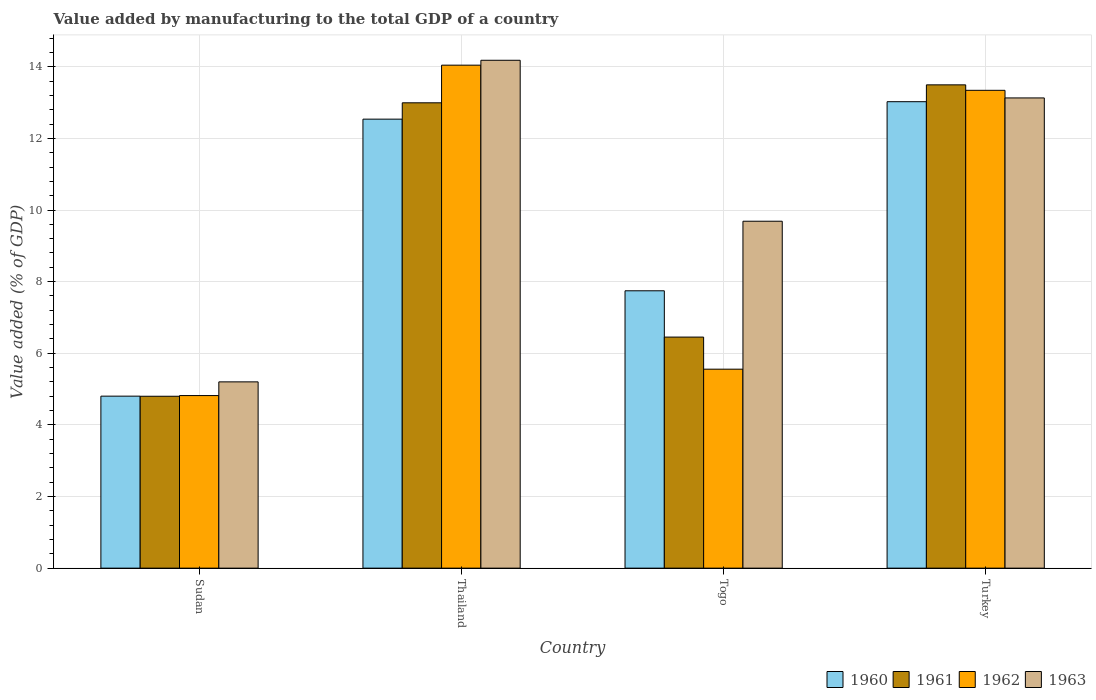How many different coloured bars are there?
Provide a succinct answer. 4. How many groups of bars are there?
Provide a succinct answer. 4. Are the number of bars per tick equal to the number of legend labels?
Offer a terse response. Yes. How many bars are there on the 2nd tick from the left?
Your response must be concise. 4. How many bars are there on the 1st tick from the right?
Keep it short and to the point. 4. What is the label of the 4th group of bars from the left?
Give a very brief answer. Turkey. What is the value added by manufacturing to the total GDP in 1962 in Thailand?
Offer a very short reply. 14.04. Across all countries, what is the maximum value added by manufacturing to the total GDP in 1960?
Offer a terse response. 13.02. Across all countries, what is the minimum value added by manufacturing to the total GDP in 1960?
Your response must be concise. 4.8. In which country was the value added by manufacturing to the total GDP in 1961 maximum?
Provide a succinct answer. Turkey. In which country was the value added by manufacturing to the total GDP in 1961 minimum?
Keep it short and to the point. Sudan. What is the total value added by manufacturing to the total GDP in 1963 in the graph?
Keep it short and to the point. 42.2. What is the difference between the value added by manufacturing to the total GDP in 1960 in Sudan and that in Togo?
Provide a short and direct response. -2.94. What is the difference between the value added by manufacturing to the total GDP in 1960 in Turkey and the value added by manufacturing to the total GDP in 1963 in Togo?
Keep it short and to the point. 3.34. What is the average value added by manufacturing to the total GDP in 1963 per country?
Offer a very short reply. 10.55. What is the difference between the value added by manufacturing to the total GDP of/in 1962 and value added by manufacturing to the total GDP of/in 1963 in Thailand?
Your answer should be compact. -0.14. In how many countries, is the value added by manufacturing to the total GDP in 1961 greater than 14 %?
Provide a succinct answer. 0. What is the ratio of the value added by manufacturing to the total GDP in 1961 in Thailand to that in Togo?
Ensure brevity in your answer.  2.01. Is the value added by manufacturing to the total GDP in 1962 in Sudan less than that in Thailand?
Offer a very short reply. Yes. Is the difference between the value added by manufacturing to the total GDP in 1962 in Sudan and Togo greater than the difference between the value added by manufacturing to the total GDP in 1963 in Sudan and Togo?
Make the answer very short. Yes. What is the difference between the highest and the second highest value added by manufacturing to the total GDP in 1963?
Offer a very short reply. -3.44. What is the difference between the highest and the lowest value added by manufacturing to the total GDP in 1961?
Your answer should be very brief. 8.69. In how many countries, is the value added by manufacturing to the total GDP in 1962 greater than the average value added by manufacturing to the total GDP in 1962 taken over all countries?
Provide a short and direct response. 2. Is the sum of the value added by manufacturing to the total GDP in 1961 in Sudan and Togo greater than the maximum value added by manufacturing to the total GDP in 1962 across all countries?
Give a very brief answer. No. Is it the case that in every country, the sum of the value added by manufacturing to the total GDP in 1960 and value added by manufacturing to the total GDP in 1963 is greater than the sum of value added by manufacturing to the total GDP in 1961 and value added by manufacturing to the total GDP in 1962?
Make the answer very short. No. What does the 2nd bar from the right in Thailand represents?
Your response must be concise. 1962. How many countries are there in the graph?
Your response must be concise. 4. What is the difference between two consecutive major ticks on the Y-axis?
Give a very brief answer. 2. Does the graph contain any zero values?
Offer a very short reply. No. Does the graph contain grids?
Provide a succinct answer. Yes. Where does the legend appear in the graph?
Your answer should be very brief. Bottom right. How many legend labels are there?
Your answer should be compact. 4. What is the title of the graph?
Your response must be concise. Value added by manufacturing to the total GDP of a country. Does "1989" appear as one of the legend labels in the graph?
Ensure brevity in your answer.  No. What is the label or title of the X-axis?
Keep it short and to the point. Country. What is the label or title of the Y-axis?
Provide a short and direct response. Value added (% of GDP). What is the Value added (% of GDP) of 1960 in Sudan?
Offer a very short reply. 4.8. What is the Value added (% of GDP) in 1961 in Sudan?
Provide a succinct answer. 4.8. What is the Value added (% of GDP) in 1962 in Sudan?
Provide a short and direct response. 4.82. What is the Value added (% of GDP) in 1963 in Sudan?
Give a very brief answer. 5.2. What is the Value added (% of GDP) of 1960 in Thailand?
Your response must be concise. 12.54. What is the Value added (% of GDP) in 1961 in Thailand?
Give a very brief answer. 12.99. What is the Value added (% of GDP) of 1962 in Thailand?
Give a very brief answer. 14.04. What is the Value added (% of GDP) in 1963 in Thailand?
Provide a succinct answer. 14.18. What is the Value added (% of GDP) of 1960 in Togo?
Give a very brief answer. 7.74. What is the Value added (% of GDP) in 1961 in Togo?
Offer a very short reply. 6.45. What is the Value added (% of GDP) of 1962 in Togo?
Provide a succinct answer. 5.56. What is the Value added (% of GDP) in 1963 in Togo?
Make the answer very short. 9.69. What is the Value added (% of GDP) of 1960 in Turkey?
Ensure brevity in your answer.  13.02. What is the Value added (% of GDP) of 1961 in Turkey?
Your response must be concise. 13.49. What is the Value added (% of GDP) in 1962 in Turkey?
Give a very brief answer. 13.34. What is the Value added (% of GDP) in 1963 in Turkey?
Offer a very short reply. 13.13. Across all countries, what is the maximum Value added (% of GDP) of 1960?
Your answer should be very brief. 13.02. Across all countries, what is the maximum Value added (% of GDP) in 1961?
Your answer should be compact. 13.49. Across all countries, what is the maximum Value added (% of GDP) of 1962?
Ensure brevity in your answer.  14.04. Across all countries, what is the maximum Value added (% of GDP) in 1963?
Provide a short and direct response. 14.18. Across all countries, what is the minimum Value added (% of GDP) in 1960?
Provide a succinct answer. 4.8. Across all countries, what is the minimum Value added (% of GDP) in 1961?
Offer a very short reply. 4.8. Across all countries, what is the minimum Value added (% of GDP) in 1962?
Give a very brief answer. 4.82. Across all countries, what is the minimum Value added (% of GDP) in 1963?
Make the answer very short. 5.2. What is the total Value added (% of GDP) in 1960 in the graph?
Make the answer very short. 38.11. What is the total Value added (% of GDP) in 1961 in the graph?
Ensure brevity in your answer.  37.74. What is the total Value added (% of GDP) in 1962 in the graph?
Your answer should be compact. 37.76. What is the total Value added (% of GDP) of 1963 in the graph?
Offer a very short reply. 42.2. What is the difference between the Value added (% of GDP) in 1960 in Sudan and that in Thailand?
Your response must be concise. -7.73. What is the difference between the Value added (% of GDP) in 1961 in Sudan and that in Thailand?
Keep it short and to the point. -8.19. What is the difference between the Value added (% of GDP) in 1962 in Sudan and that in Thailand?
Make the answer very short. -9.23. What is the difference between the Value added (% of GDP) in 1963 in Sudan and that in Thailand?
Offer a very short reply. -8.98. What is the difference between the Value added (% of GDP) of 1960 in Sudan and that in Togo?
Provide a succinct answer. -2.94. What is the difference between the Value added (% of GDP) of 1961 in Sudan and that in Togo?
Keep it short and to the point. -1.65. What is the difference between the Value added (% of GDP) in 1962 in Sudan and that in Togo?
Ensure brevity in your answer.  -0.74. What is the difference between the Value added (% of GDP) in 1963 in Sudan and that in Togo?
Offer a terse response. -4.49. What is the difference between the Value added (% of GDP) in 1960 in Sudan and that in Turkey?
Provide a short and direct response. -8.22. What is the difference between the Value added (% of GDP) in 1961 in Sudan and that in Turkey?
Your response must be concise. -8.69. What is the difference between the Value added (% of GDP) in 1962 in Sudan and that in Turkey?
Ensure brevity in your answer.  -8.52. What is the difference between the Value added (% of GDP) in 1963 in Sudan and that in Turkey?
Offer a terse response. -7.93. What is the difference between the Value added (% of GDP) in 1960 in Thailand and that in Togo?
Provide a succinct answer. 4.79. What is the difference between the Value added (% of GDP) of 1961 in Thailand and that in Togo?
Provide a short and direct response. 6.54. What is the difference between the Value added (% of GDP) in 1962 in Thailand and that in Togo?
Offer a terse response. 8.49. What is the difference between the Value added (% of GDP) in 1963 in Thailand and that in Togo?
Keep it short and to the point. 4.49. What is the difference between the Value added (% of GDP) of 1960 in Thailand and that in Turkey?
Make the answer very short. -0.49. What is the difference between the Value added (% of GDP) of 1961 in Thailand and that in Turkey?
Offer a very short reply. -0.5. What is the difference between the Value added (% of GDP) of 1962 in Thailand and that in Turkey?
Ensure brevity in your answer.  0.7. What is the difference between the Value added (% of GDP) of 1963 in Thailand and that in Turkey?
Give a very brief answer. 1.05. What is the difference between the Value added (% of GDP) of 1960 in Togo and that in Turkey?
Provide a short and direct response. -5.28. What is the difference between the Value added (% of GDP) in 1961 in Togo and that in Turkey?
Your answer should be very brief. -7.04. What is the difference between the Value added (% of GDP) of 1962 in Togo and that in Turkey?
Provide a succinct answer. -7.79. What is the difference between the Value added (% of GDP) of 1963 in Togo and that in Turkey?
Provide a succinct answer. -3.44. What is the difference between the Value added (% of GDP) of 1960 in Sudan and the Value added (% of GDP) of 1961 in Thailand?
Give a very brief answer. -8.19. What is the difference between the Value added (% of GDP) of 1960 in Sudan and the Value added (% of GDP) of 1962 in Thailand?
Give a very brief answer. -9.24. What is the difference between the Value added (% of GDP) of 1960 in Sudan and the Value added (% of GDP) of 1963 in Thailand?
Keep it short and to the point. -9.38. What is the difference between the Value added (% of GDP) in 1961 in Sudan and the Value added (% of GDP) in 1962 in Thailand?
Provide a succinct answer. -9.24. What is the difference between the Value added (% of GDP) of 1961 in Sudan and the Value added (% of GDP) of 1963 in Thailand?
Offer a very short reply. -9.38. What is the difference between the Value added (% of GDP) in 1962 in Sudan and the Value added (% of GDP) in 1963 in Thailand?
Give a very brief answer. -9.36. What is the difference between the Value added (% of GDP) of 1960 in Sudan and the Value added (% of GDP) of 1961 in Togo?
Give a very brief answer. -1.65. What is the difference between the Value added (% of GDP) in 1960 in Sudan and the Value added (% of GDP) in 1962 in Togo?
Provide a short and direct response. -0.75. What is the difference between the Value added (% of GDP) of 1960 in Sudan and the Value added (% of GDP) of 1963 in Togo?
Offer a very short reply. -4.88. What is the difference between the Value added (% of GDP) in 1961 in Sudan and the Value added (% of GDP) in 1962 in Togo?
Ensure brevity in your answer.  -0.76. What is the difference between the Value added (% of GDP) of 1961 in Sudan and the Value added (% of GDP) of 1963 in Togo?
Provide a succinct answer. -4.89. What is the difference between the Value added (% of GDP) in 1962 in Sudan and the Value added (% of GDP) in 1963 in Togo?
Your answer should be compact. -4.87. What is the difference between the Value added (% of GDP) of 1960 in Sudan and the Value added (% of GDP) of 1961 in Turkey?
Offer a terse response. -8.69. What is the difference between the Value added (% of GDP) in 1960 in Sudan and the Value added (% of GDP) in 1962 in Turkey?
Make the answer very short. -8.54. What is the difference between the Value added (% of GDP) in 1960 in Sudan and the Value added (% of GDP) in 1963 in Turkey?
Offer a very short reply. -8.33. What is the difference between the Value added (% of GDP) of 1961 in Sudan and the Value added (% of GDP) of 1962 in Turkey?
Your response must be concise. -8.54. What is the difference between the Value added (% of GDP) in 1961 in Sudan and the Value added (% of GDP) in 1963 in Turkey?
Offer a very short reply. -8.33. What is the difference between the Value added (% of GDP) in 1962 in Sudan and the Value added (% of GDP) in 1963 in Turkey?
Make the answer very short. -8.31. What is the difference between the Value added (% of GDP) in 1960 in Thailand and the Value added (% of GDP) in 1961 in Togo?
Your answer should be very brief. 6.09. What is the difference between the Value added (% of GDP) in 1960 in Thailand and the Value added (% of GDP) in 1962 in Togo?
Keep it short and to the point. 6.98. What is the difference between the Value added (% of GDP) of 1960 in Thailand and the Value added (% of GDP) of 1963 in Togo?
Your answer should be very brief. 2.85. What is the difference between the Value added (% of GDP) of 1961 in Thailand and the Value added (% of GDP) of 1962 in Togo?
Make the answer very short. 7.44. What is the difference between the Value added (% of GDP) in 1961 in Thailand and the Value added (% of GDP) in 1963 in Togo?
Your answer should be very brief. 3.31. What is the difference between the Value added (% of GDP) in 1962 in Thailand and the Value added (% of GDP) in 1963 in Togo?
Offer a terse response. 4.36. What is the difference between the Value added (% of GDP) in 1960 in Thailand and the Value added (% of GDP) in 1961 in Turkey?
Your answer should be compact. -0.96. What is the difference between the Value added (% of GDP) in 1960 in Thailand and the Value added (% of GDP) in 1962 in Turkey?
Ensure brevity in your answer.  -0.81. What is the difference between the Value added (% of GDP) in 1960 in Thailand and the Value added (% of GDP) in 1963 in Turkey?
Your answer should be compact. -0.59. What is the difference between the Value added (% of GDP) of 1961 in Thailand and the Value added (% of GDP) of 1962 in Turkey?
Your answer should be very brief. -0.35. What is the difference between the Value added (% of GDP) of 1961 in Thailand and the Value added (% of GDP) of 1963 in Turkey?
Your answer should be compact. -0.14. What is the difference between the Value added (% of GDP) of 1962 in Thailand and the Value added (% of GDP) of 1963 in Turkey?
Keep it short and to the point. 0.92. What is the difference between the Value added (% of GDP) of 1960 in Togo and the Value added (% of GDP) of 1961 in Turkey?
Your answer should be very brief. -5.75. What is the difference between the Value added (% of GDP) of 1960 in Togo and the Value added (% of GDP) of 1962 in Turkey?
Make the answer very short. -5.6. What is the difference between the Value added (% of GDP) of 1960 in Togo and the Value added (% of GDP) of 1963 in Turkey?
Offer a very short reply. -5.38. What is the difference between the Value added (% of GDP) of 1961 in Togo and the Value added (% of GDP) of 1962 in Turkey?
Give a very brief answer. -6.89. What is the difference between the Value added (% of GDP) in 1961 in Togo and the Value added (% of GDP) in 1963 in Turkey?
Offer a terse response. -6.68. What is the difference between the Value added (% of GDP) of 1962 in Togo and the Value added (% of GDP) of 1963 in Turkey?
Your answer should be very brief. -7.57. What is the average Value added (% of GDP) in 1960 per country?
Keep it short and to the point. 9.53. What is the average Value added (% of GDP) in 1961 per country?
Provide a short and direct response. 9.43. What is the average Value added (% of GDP) in 1962 per country?
Keep it short and to the point. 9.44. What is the average Value added (% of GDP) in 1963 per country?
Your response must be concise. 10.55. What is the difference between the Value added (% of GDP) of 1960 and Value added (% of GDP) of 1961 in Sudan?
Keep it short and to the point. 0. What is the difference between the Value added (% of GDP) of 1960 and Value added (% of GDP) of 1962 in Sudan?
Give a very brief answer. -0.02. What is the difference between the Value added (% of GDP) in 1960 and Value added (% of GDP) in 1963 in Sudan?
Ensure brevity in your answer.  -0.4. What is the difference between the Value added (% of GDP) in 1961 and Value added (% of GDP) in 1962 in Sudan?
Offer a very short reply. -0.02. What is the difference between the Value added (% of GDP) in 1961 and Value added (% of GDP) in 1963 in Sudan?
Keep it short and to the point. -0.4. What is the difference between the Value added (% of GDP) in 1962 and Value added (% of GDP) in 1963 in Sudan?
Make the answer very short. -0.38. What is the difference between the Value added (% of GDP) in 1960 and Value added (% of GDP) in 1961 in Thailand?
Provide a short and direct response. -0.46. What is the difference between the Value added (% of GDP) in 1960 and Value added (% of GDP) in 1962 in Thailand?
Offer a very short reply. -1.51. What is the difference between the Value added (% of GDP) of 1960 and Value added (% of GDP) of 1963 in Thailand?
Provide a succinct answer. -1.64. What is the difference between the Value added (% of GDP) of 1961 and Value added (% of GDP) of 1962 in Thailand?
Offer a terse response. -1.05. What is the difference between the Value added (% of GDP) of 1961 and Value added (% of GDP) of 1963 in Thailand?
Offer a very short reply. -1.19. What is the difference between the Value added (% of GDP) in 1962 and Value added (% of GDP) in 1963 in Thailand?
Offer a terse response. -0.14. What is the difference between the Value added (% of GDP) of 1960 and Value added (% of GDP) of 1961 in Togo?
Offer a very short reply. 1.29. What is the difference between the Value added (% of GDP) of 1960 and Value added (% of GDP) of 1962 in Togo?
Your answer should be compact. 2.19. What is the difference between the Value added (% of GDP) of 1960 and Value added (% of GDP) of 1963 in Togo?
Your answer should be compact. -1.94. What is the difference between the Value added (% of GDP) in 1961 and Value added (% of GDP) in 1962 in Togo?
Ensure brevity in your answer.  0.9. What is the difference between the Value added (% of GDP) of 1961 and Value added (% of GDP) of 1963 in Togo?
Offer a terse response. -3.23. What is the difference between the Value added (% of GDP) in 1962 and Value added (% of GDP) in 1963 in Togo?
Give a very brief answer. -4.13. What is the difference between the Value added (% of GDP) in 1960 and Value added (% of GDP) in 1961 in Turkey?
Offer a terse response. -0.47. What is the difference between the Value added (% of GDP) in 1960 and Value added (% of GDP) in 1962 in Turkey?
Provide a short and direct response. -0.32. What is the difference between the Value added (% of GDP) in 1960 and Value added (% of GDP) in 1963 in Turkey?
Offer a very short reply. -0.11. What is the difference between the Value added (% of GDP) in 1961 and Value added (% of GDP) in 1962 in Turkey?
Provide a succinct answer. 0.15. What is the difference between the Value added (% of GDP) of 1961 and Value added (% of GDP) of 1963 in Turkey?
Provide a short and direct response. 0.37. What is the difference between the Value added (% of GDP) of 1962 and Value added (% of GDP) of 1963 in Turkey?
Give a very brief answer. 0.21. What is the ratio of the Value added (% of GDP) in 1960 in Sudan to that in Thailand?
Give a very brief answer. 0.38. What is the ratio of the Value added (% of GDP) of 1961 in Sudan to that in Thailand?
Make the answer very short. 0.37. What is the ratio of the Value added (% of GDP) in 1962 in Sudan to that in Thailand?
Give a very brief answer. 0.34. What is the ratio of the Value added (% of GDP) in 1963 in Sudan to that in Thailand?
Your response must be concise. 0.37. What is the ratio of the Value added (% of GDP) in 1960 in Sudan to that in Togo?
Ensure brevity in your answer.  0.62. What is the ratio of the Value added (% of GDP) in 1961 in Sudan to that in Togo?
Ensure brevity in your answer.  0.74. What is the ratio of the Value added (% of GDP) of 1962 in Sudan to that in Togo?
Make the answer very short. 0.87. What is the ratio of the Value added (% of GDP) of 1963 in Sudan to that in Togo?
Your response must be concise. 0.54. What is the ratio of the Value added (% of GDP) of 1960 in Sudan to that in Turkey?
Make the answer very short. 0.37. What is the ratio of the Value added (% of GDP) in 1961 in Sudan to that in Turkey?
Keep it short and to the point. 0.36. What is the ratio of the Value added (% of GDP) in 1962 in Sudan to that in Turkey?
Offer a very short reply. 0.36. What is the ratio of the Value added (% of GDP) in 1963 in Sudan to that in Turkey?
Offer a very short reply. 0.4. What is the ratio of the Value added (% of GDP) of 1960 in Thailand to that in Togo?
Provide a short and direct response. 1.62. What is the ratio of the Value added (% of GDP) of 1961 in Thailand to that in Togo?
Provide a short and direct response. 2.01. What is the ratio of the Value added (% of GDP) in 1962 in Thailand to that in Togo?
Keep it short and to the point. 2.53. What is the ratio of the Value added (% of GDP) of 1963 in Thailand to that in Togo?
Your answer should be very brief. 1.46. What is the ratio of the Value added (% of GDP) of 1960 in Thailand to that in Turkey?
Your answer should be very brief. 0.96. What is the ratio of the Value added (% of GDP) of 1961 in Thailand to that in Turkey?
Give a very brief answer. 0.96. What is the ratio of the Value added (% of GDP) in 1962 in Thailand to that in Turkey?
Offer a terse response. 1.05. What is the ratio of the Value added (% of GDP) of 1963 in Thailand to that in Turkey?
Offer a very short reply. 1.08. What is the ratio of the Value added (% of GDP) in 1960 in Togo to that in Turkey?
Give a very brief answer. 0.59. What is the ratio of the Value added (% of GDP) in 1961 in Togo to that in Turkey?
Your answer should be compact. 0.48. What is the ratio of the Value added (% of GDP) in 1962 in Togo to that in Turkey?
Your answer should be compact. 0.42. What is the ratio of the Value added (% of GDP) in 1963 in Togo to that in Turkey?
Offer a terse response. 0.74. What is the difference between the highest and the second highest Value added (% of GDP) of 1960?
Offer a very short reply. 0.49. What is the difference between the highest and the second highest Value added (% of GDP) in 1961?
Make the answer very short. 0.5. What is the difference between the highest and the second highest Value added (% of GDP) of 1962?
Your answer should be compact. 0.7. What is the difference between the highest and the second highest Value added (% of GDP) in 1963?
Provide a short and direct response. 1.05. What is the difference between the highest and the lowest Value added (% of GDP) in 1960?
Offer a terse response. 8.22. What is the difference between the highest and the lowest Value added (% of GDP) in 1961?
Ensure brevity in your answer.  8.69. What is the difference between the highest and the lowest Value added (% of GDP) in 1962?
Offer a terse response. 9.23. What is the difference between the highest and the lowest Value added (% of GDP) of 1963?
Provide a succinct answer. 8.98. 